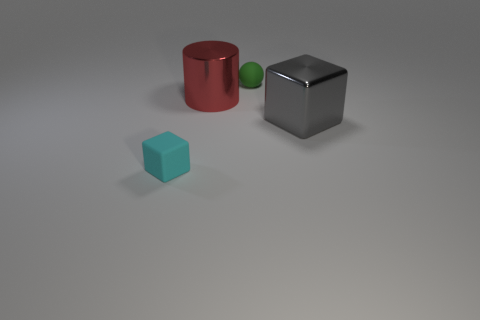Add 2 gray metallic things. How many objects exist? 6 Subtract all cylinders. How many objects are left? 3 Subtract 0 yellow cylinders. How many objects are left? 4 Subtract all green cubes. Subtract all brown balls. How many cubes are left? 2 Subtract all small green things. Subtract all small things. How many objects are left? 1 Add 1 green things. How many green things are left? 2 Add 4 tiny cyan things. How many tiny cyan things exist? 5 